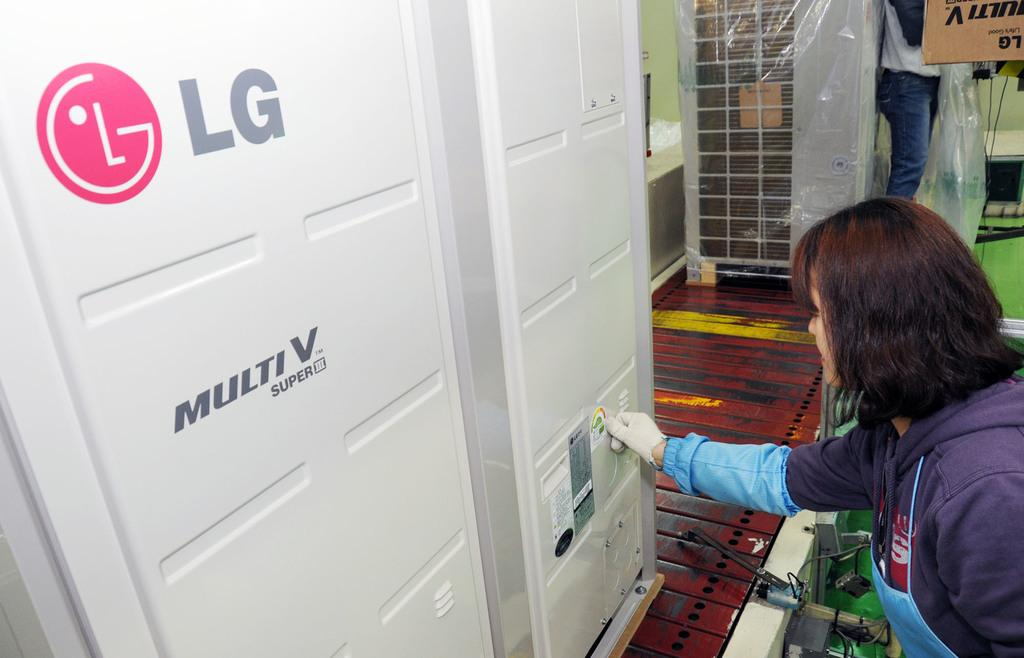<image>
Relay a brief, clear account of the picture shown. A woman wearing white gloves examines the tags affixed to large LG Multi V super computer equipment. 